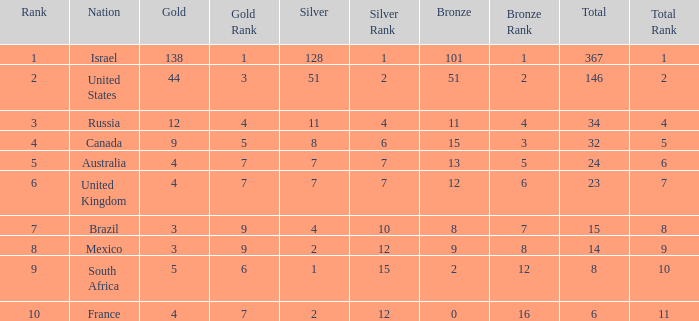What is the maximum number of silvers for a country with fewer than 12 golds and a total less than 8? 2.0. 